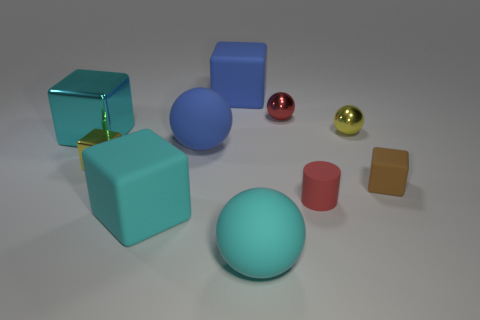Subtract all yellow metallic spheres. How many spheres are left? 3 Subtract all cyan spheres. How many spheres are left? 3 Subtract 1 blocks. How many blocks are left? 4 Add 7 large blue blocks. How many large blue blocks are left? 8 Add 10 tiny blue cylinders. How many tiny blue cylinders exist? 10 Subtract 0 red blocks. How many objects are left? 10 Subtract all cylinders. How many objects are left? 9 Subtract all yellow balls. Subtract all blue cylinders. How many balls are left? 3 Subtract all green balls. How many cyan cylinders are left? 0 Subtract all tiny red objects. Subtract all red spheres. How many objects are left? 7 